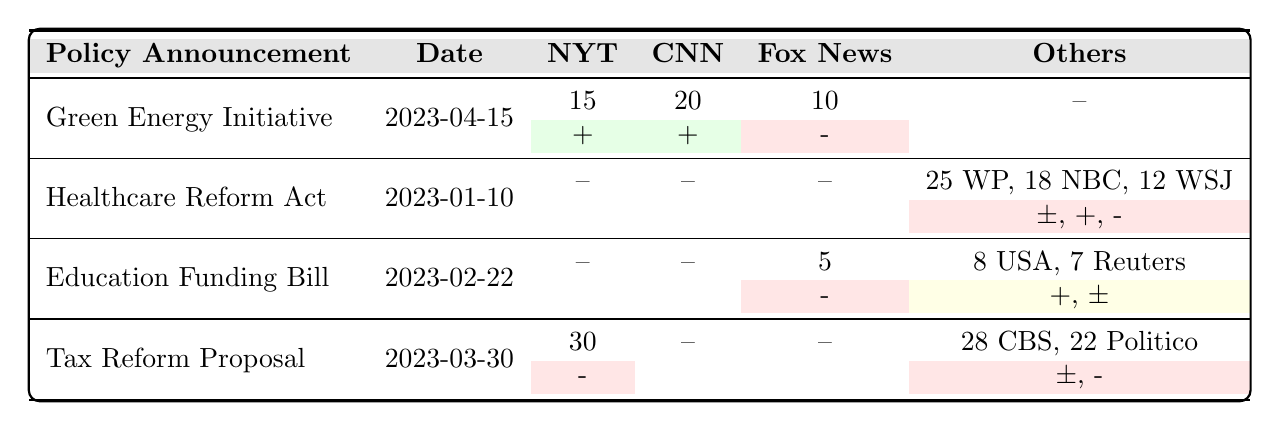What is the total frequency of mentions for the Green Energy Initiative? To find the total frequency of mentions, we look at the values in the row for the Green Energy Initiative; 15 (NYT) + 20 (CNN) + 10 (Fox News) = 45.
Answer: 45 Which news outlet mentioned the Healthcare Reform Act the most? The frequencies for the Healthcare Reform Act are: The Washington Post (25), NBC News (18), and The Wall Street Journal (12). The highest frequency is from The Washington Post at 25.
Answer: The Washington Post Was the sentiment for the Education Funding Bill overall positive? The mentions for the Education Funding Bill include positive (8), negative (5), and mixed (7). Since one mention is negative, the overall sentiment cannot be purely positive; it is mixed.
Answer: No How many news outlets mentioned the Tax Reform Proposal? The Tax Reform Proposal is mentioned by The New York Times (30), CBS News (28), and Politico (22). The total number of news outlets is three.
Answer: 3 What is the average frequency of mentions for policies with a positive sentiment? The positive sentiment counts are: Green Energy Initiative (15 + 20), Healthcare Reform Act (18), and Education Funding Bill (8). Adding these gives (15 + 20 + 18 + 8) = 61, and there are 4 mentions; thus, the average is 61/4 = 15.25.
Answer: 15.25 Which policy announcement had the highest negative sentiment mentions? The negative sentiment counts are: Green Energy Initiative (10 - Fox News), Tax Reform Proposal (30 - NYT, 22 - Politico), and Education Funding Bill (5 - Fox News). The highest count of negative mentions is 30 for the Tax Reform Proposal.
Answer: Tax Reform Proposal Is there a positive sentiment mention from Fox News for any policy announcement? According to the data, Fox News has a negative sentiment mention for the Green Energy Initiative and the Education Funding Bill, and it has a negative sentiment for its mention of 5 in the Education Funding Bill. Therefore, there are no positive sentiment mentions from Fox News.
Answer: No Which policy announcement received mixed sentiment mentions, and how many were there? The policies with mixed sentiment are the Healthcare Reform Act (25 - WP, 18 - NBC, 12 - WSJ) and the Education Funding Bill (7 - Reuters). The total mixed sentiment mentions are 25 (WP) + 18 (NBC) + 12 (WSJ) + 7 (Reuters) = 62.
Answer: 62 Which outlet had the most overall mentions across all policy announcements? To find the outlet with the most mentions, we total the frequencies: NYT (15 + 30), CNN (20 + 0), Fox News (10 + 5), and others combined (25 + 18 - WP, NBC, WSJ). NYT has 45, CNN has 20, Fox has 15, and others total up to 25. Hence, the New York Times with 45 mentions tops the chart.
Answer: The New York Times 